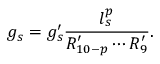Convert formula to latex. <formula><loc_0><loc_0><loc_500><loc_500>g _ { s } = g _ { s } ^ { \prime } \frac { l _ { s } ^ { p } } { R _ { 1 0 - p } ^ { \prime } \cdots R _ { 9 } ^ { \prime } } .</formula> 